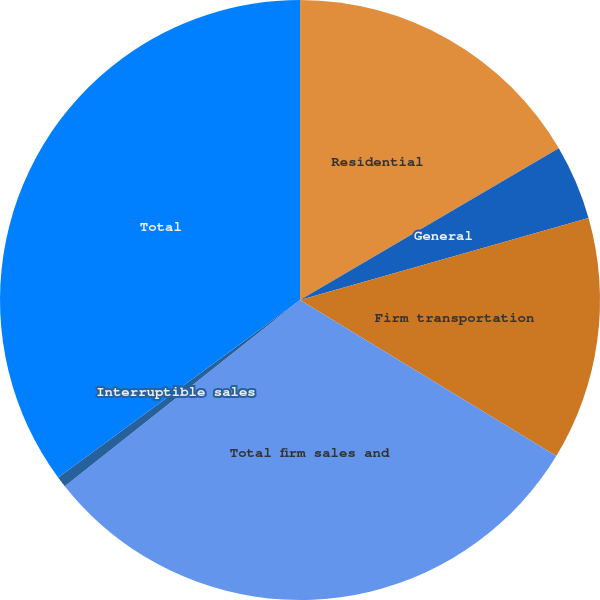<chart> <loc_0><loc_0><loc_500><loc_500><pie_chart><fcel>Residential<fcel>General<fcel>Firm transportation<fcel>Total firm sales and<fcel>Interruptible sales<fcel>Total<nl><fcel>16.56%<fcel>4.03%<fcel>13.11%<fcel>30.65%<fcel>0.58%<fcel>35.08%<nl></chart> 